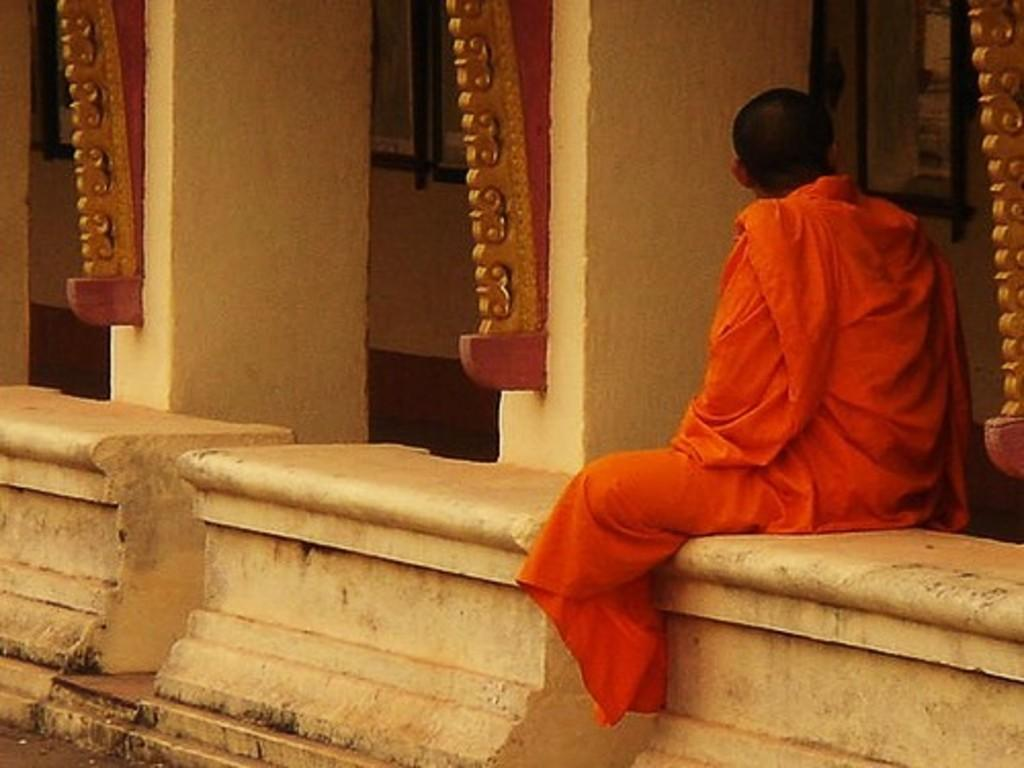What is the person in the image doing? There is a person sitting in the image. What architectural features can be seen in the image? There are pillars in the image. What can be seen through the windows in the image? There are windows in the image. Where is the person's dad in the image? There is no mention of a dad in the image, so it cannot be determined where he might be. 